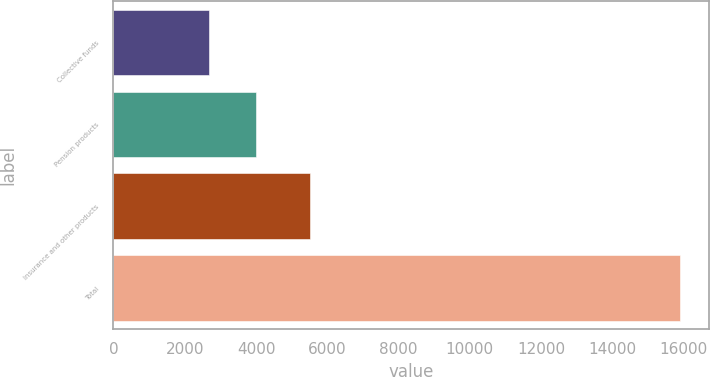<chart> <loc_0><loc_0><loc_500><loc_500><bar_chart><fcel>Collective funds<fcel>Pension products<fcel>Insurance and other products<fcel>Total<nl><fcel>2679<fcel>4001.8<fcel>5514<fcel>15907<nl></chart> 